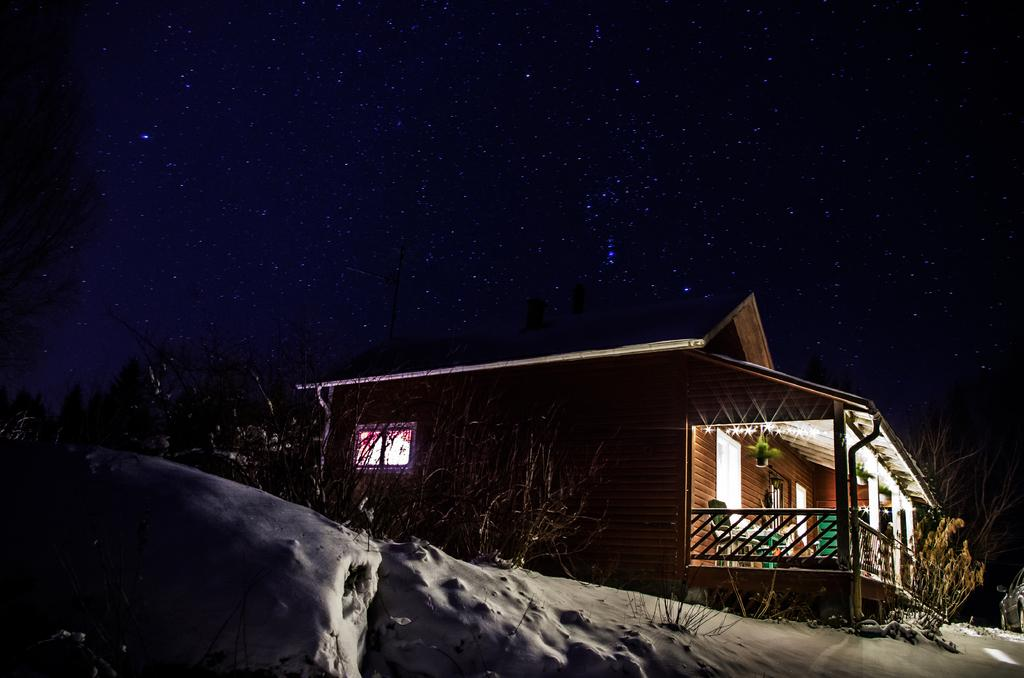What type of structure is present in the image? There is a house in the image. What can be seen at the top of the image? The sky is visible at the top of the image. What type of vegetation is in front of the house in the image? There are trees in front of the house in the image. Can you see any signs of trouble at the seashore in the image? There is no seashore present in the image, and therefore no signs of trouble can be observed. How many stitches are visible on the house in the image? There are no stitches visible on the house in the image. 